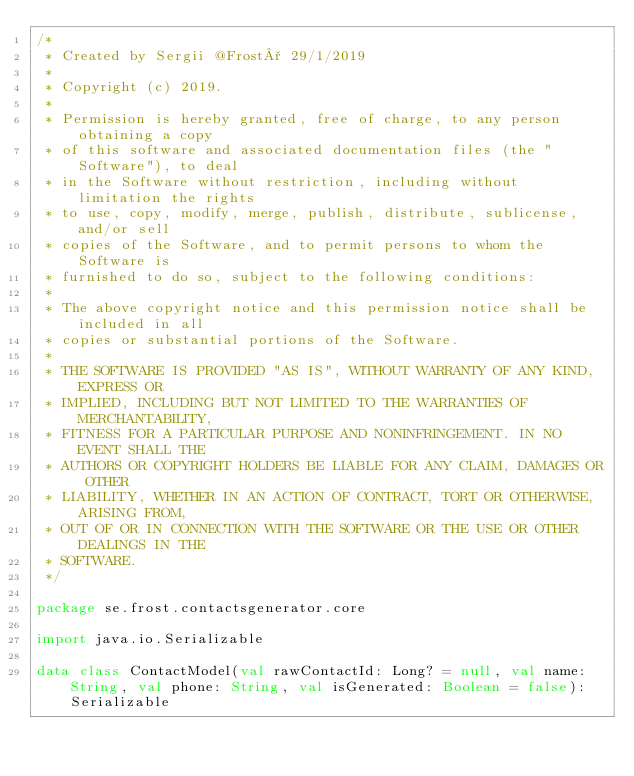<code> <loc_0><loc_0><loc_500><loc_500><_Kotlin_>/*
 * Created by Sergii @Frost° 29/1/2019
 *
 * Copyright (c) 2019.
 *
 * Permission is hereby granted, free of charge, to any person obtaining a copy
 * of this software and associated documentation files (the "Software"), to deal
 * in the Software without restriction, including without limitation the rights
 * to use, copy, modify, merge, publish, distribute, sublicense, and/or sell
 * copies of the Software, and to permit persons to whom the Software is
 * furnished to do so, subject to the following conditions:
 *
 * The above copyright notice and this permission notice shall be included in all
 * copies or substantial portions of the Software.
 *
 * THE SOFTWARE IS PROVIDED "AS IS", WITHOUT WARRANTY OF ANY KIND, EXPRESS OR
 * IMPLIED, INCLUDING BUT NOT LIMITED TO THE WARRANTIES OF MERCHANTABILITY,
 * FITNESS FOR A PARTICULAR PURPOSE AND NONINFRINGEMENT. IN NO EVENT SHALL THE
 * AUTHORS OR COPYRIGHT HOLDERS BE LIABLE FOR ANY CLAIM, DAMAGES OR OTHER
 * LIABILITY, WHETHER IN AN ACTION OF CONTRACT, TORT OR OTHERWISE, ARISING FROM,
 * OUT OF OR IN CONNECTION WITH THE SOFTWARE OR THE USE OR OTHER DEALINGS IN THE
 * SOFTWARE.
 */

package se.frost.contactsgenerator.core

import java.io.Serializable

data class ContactModel(val rawContactId: Long? = null, val name: String, val phone: String, val isGenerated: Boolean = false): Serializable</code> 